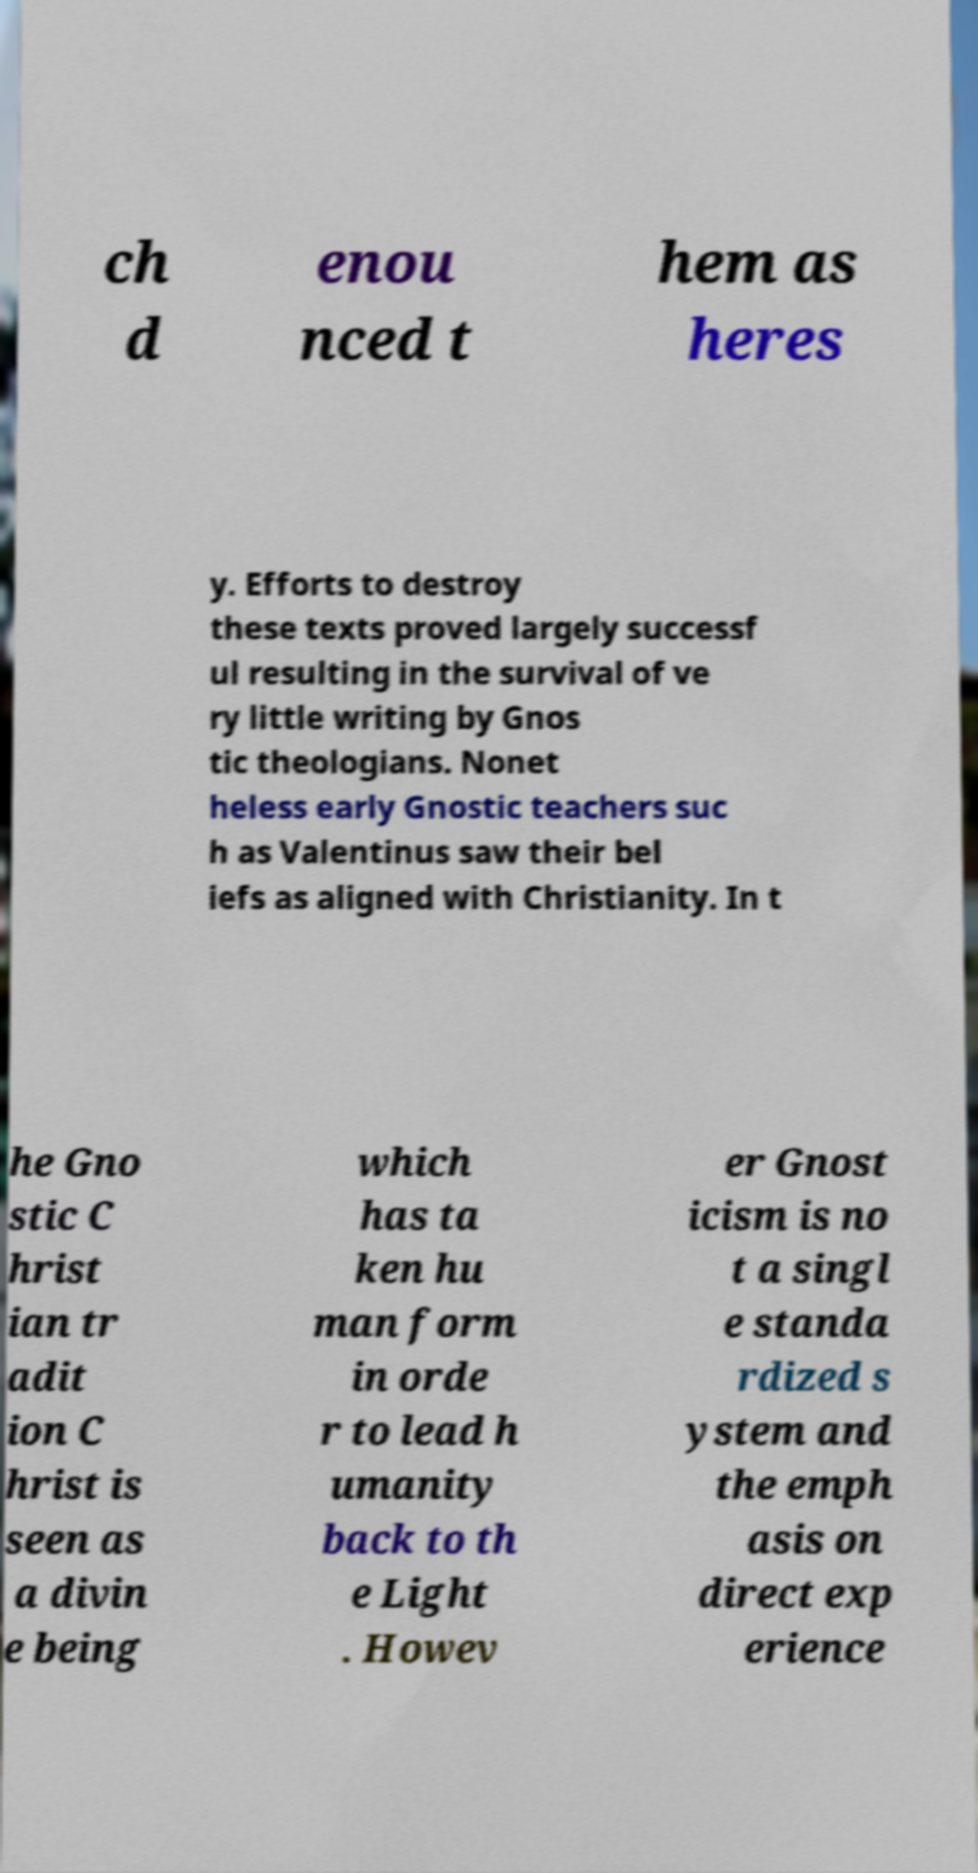There's text embedded in this image that I need extracted. Can you transcribe it verbatim? ch d enou nced t hem as heres y. Efforts to destroy these texts proved largely successf ul resulting in the survival of ve ry little writing by Gnos tic theologians. Nonet heless early Gnostic teachers suc h as Valentinus saw their bel iefs as aligned with Christianity. In t he Gno stic C hrist ian tr adit ion C hrist is seen as a divin e being which has ta ken hu man form in orde r to lead h umanity back to th e Light . Howev er Gnost icism is no t a singl e standa rdized s ystem and the emph asis on direct exp erience 